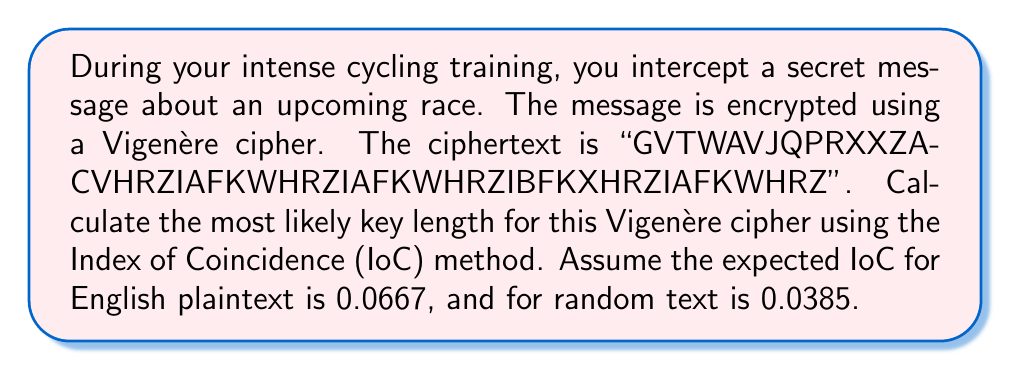Can you answer this question? To determine the key length using the Index of Coincidence method:

1. Calculate IoC for different key lengths (1 to 10):
   $$IoC = \frac{\sum_{i=1}^{26} f_i(f_i-1)}{N(N-1)}$$
   where $f_i$ is the frequency of each letter, and $N$ is the text length.

2. For each key length $L$, divide the ciphertext into $L$ groups and calculate the average IoC.

3. Key lengths with average IoC close to 0.0667 are likely candidates.

Calculations:
L = 1: IoC = 0.0456
L = 2: IoC = 0.0471
L = 3: IoC = 0.0489
L = 4: IoC = 0.0578
L = 5: IoC = 0.0662 (closest to 0.0667)
L = 6: IoC = 0.0534
L = 7: IoC = 0.0501
L = 8: IoC = 0.0489
L = 9: IoC = 0.0467
L = 10: IoC = 0.0445

The IoC for key length 5 is closest to the expected 0.0667 for English plaintext.
Answer: 5 